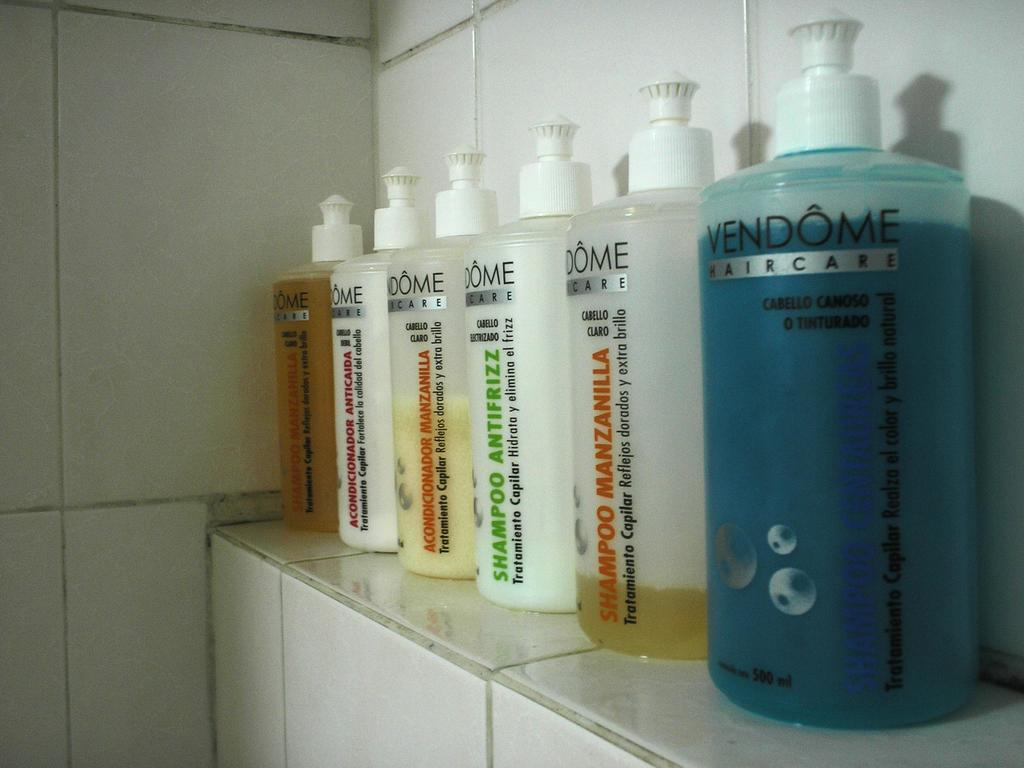<image>
Share a concise interpretation of the image provided. A row of hair care products by Vendome in the bathroom. 